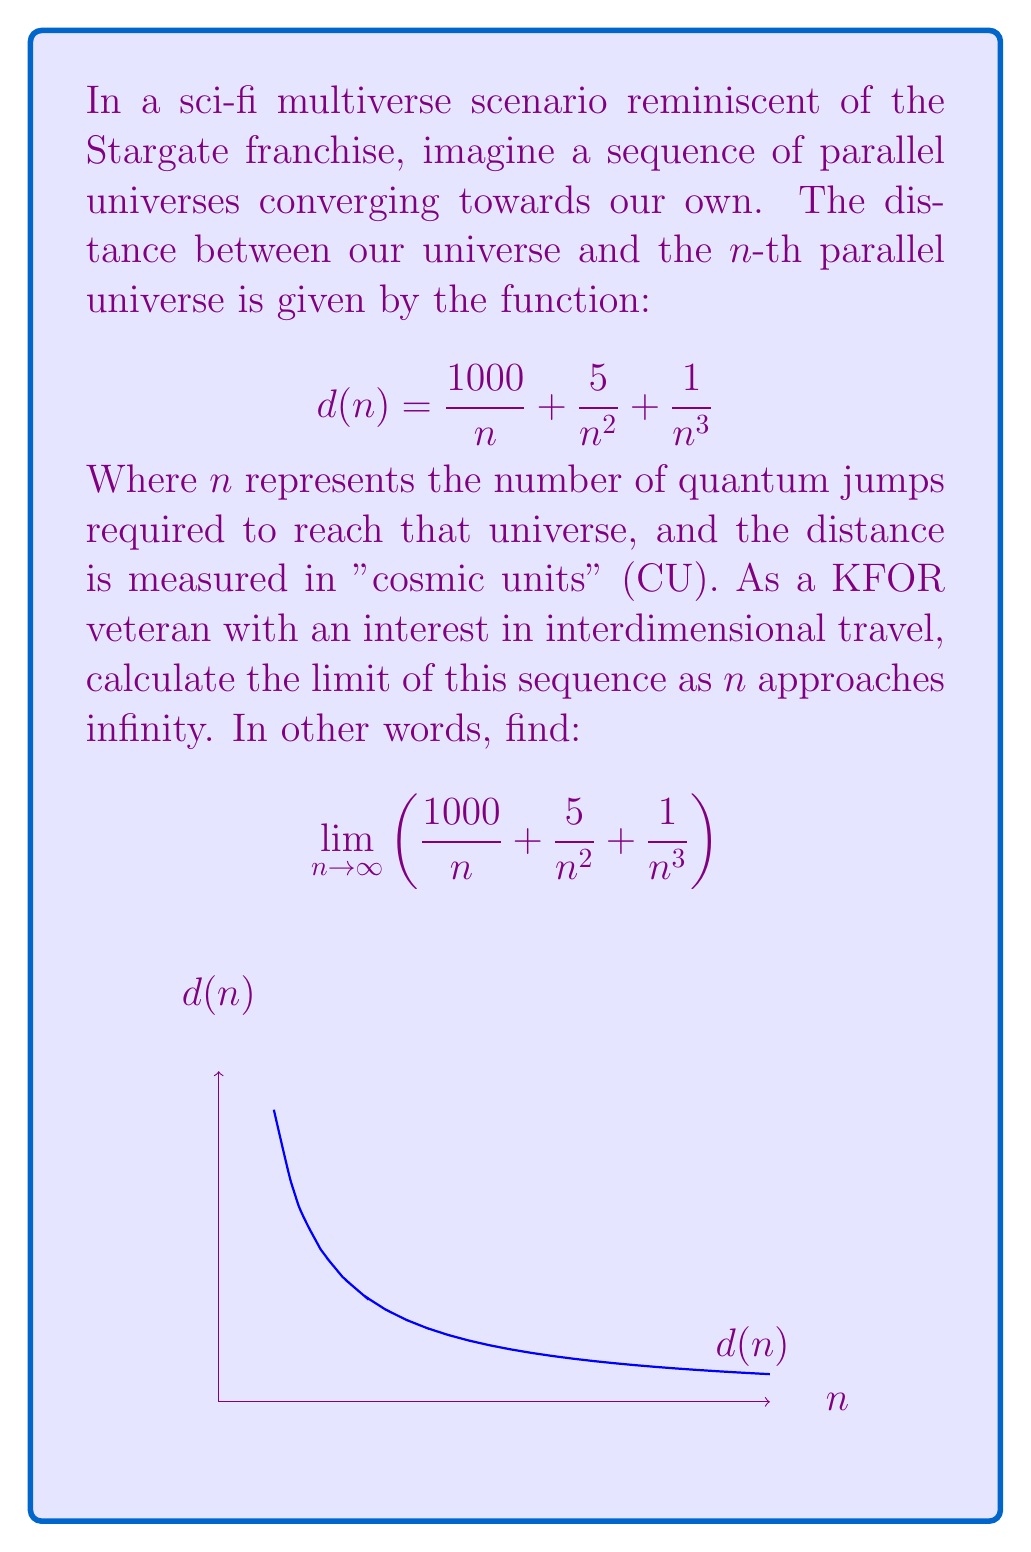Could you help me with this problem? To solve this limit, we'll analyze each term separately as n approaches infinity:

1) First term: $\lim_{n \to \infty} \frac{1000}{n}$
   As n grows infinitely large, this fraction approaches 0.

2) Second term: $\lim_{n \to \infty} \frac{5}{n^2}$
   This term approaches 0 even faster than the first term as n grows.

3) Third term: $\lim_{n \to \infty} \frac{1}{n^3}$
   This term approaches 0 the fastest of all three terms.

Now, we can use the limit laws to combine these results:

$$\lim_{n \to \infty} \left(\frac{1000}{n} + \frac{5}{n^2} + \frac{1}{n^3}\right) = \lim_{n \to \infty} \frac{1000}{n} + \lim_{n \to \infty} \frac{5}{n^2} + \lim_{n \to \infty} \frac{1}{n^3}$$

$$= 0 + 0 + 0 = 0$$

Therefore, as the number of quantum jumps (n) approaches infinity, the distance between our universe and the n-th parallel universe converges to 0 CU.
Answer: 0 CU 